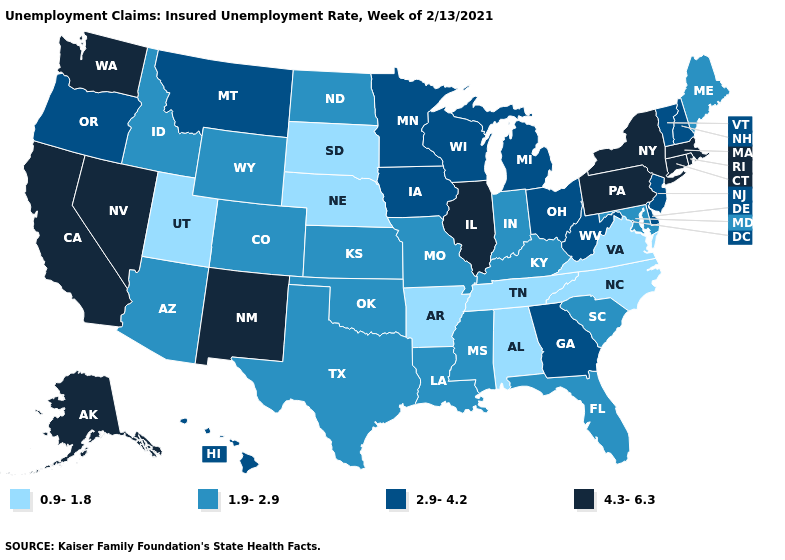Name the states that have a value in the range 0.9-1.8?
Be succinct. Alabama, Arkansas, Nebraska, North Carolina, South Dakota, Tennessee, Utah, Virginia. Name the states that have a value in the range 1.9-2.9?
Short answer required. Arizona, Colorado, Florida, Idaho, Indiana, Kansas, Kentucky, Louisiana, Maine, Maryland, Mississippi, Missouri, North Dakota, Oklahoma, South Carolina, Texas, Wyoming. What is the value of Kentucky?
Quick response, please. 1.9-2.9. Which states hav the highest value in the West?
Give a very brief answer. Alaska, California, Nevada, New Mexico, Washington. Which states have the lowest value in the USA?
Be succinct. Alabama, Arkansas, Nebraska, North Carolina, South Dakota, Tennessee, Utah, Virginia. What is the value of Louisiana?
Quick response, please. 1.9-2.9. Name the states that have a value in the range 4.3-6.3?
Short answer required. Alaska, California, Connecticut, Illinois, Massachusetts, Nevada, New Mexico, New York, Pennsylvania, Rhode Island, Washington. What is the lowest value in the MidWest?
Answer briefly. 0.9-1.8. Does the map have missing data?
Concise answer only. No. Name the states that have a value in the range 2.9-4.2?
Short answer required. Delaware, Georgia, Hawaii, Iowa, Michigan, Minnesota, Montana, New Hampshire, New Jersey, Ohio, Oregon, Vermont, West Virginia, Wisconsin. What is the value of Kansas?
Give a very brief answer. 1.9-2.9. What is the value of Nebraska?
Be succinct. 0.9-1.8. Name the states that have a value in the range 2.9-4.2?
Keep it brief. Delaware, Georgia, Hawaii, Iowa, Michigan, Minnesota, Montana, New Hampshire, New Jersey, Ohio, Oregon, Vermont, West Virginia, Wisconsin. Which states hav the highest value in the South?
Quick response, please. Delaware, Georgia, West Virginia. Does the map have missing data?
Give a very brief answer. No. 